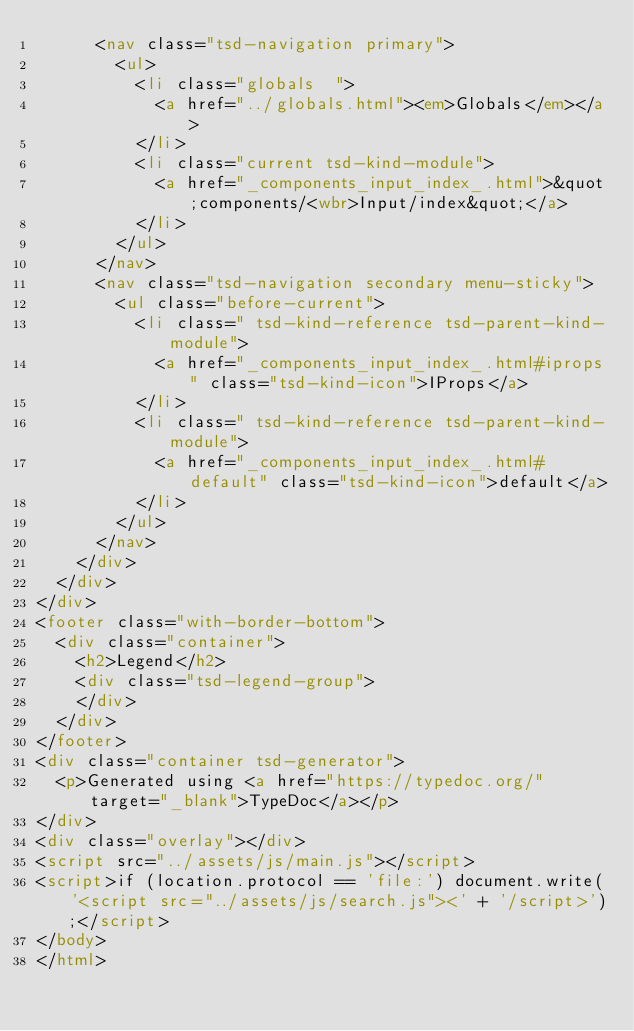Convert code to text. <code><loc_0><loc_0><loc_500><loc_500><_HTML_>			<nav class="tsd-navigation primary">
				<ul>
					<li class="globals  ">
						<a href="../globals.html"><em>Globals</em></a>
					</li>
					<li class="current tsd-kind-module">
						<a href="_components_input_index_.html">&quot;components/<wbr>Input/index&quot;</a>
					</li>
				</ul>
			</nav>
			<nav class="tsd-navigation secondary menu-sticky">
				<ul class="before-current">
					<li class=" tsd-kind-reference tsd-parent-kind-module">
						<a href="_components_input_index_.html#iprops" class="tsd-kind-icon">IProps</a>
					</li>
					<li class=" tsd-kind-reference tsd-parent-kind-module">
						<a href="_components_input_index_.html#default" class="tsd-kind-icon">default</a>
					</li>
				</ul>
			</nav>
		</div>
	</div>
</div>
<footer class="with-border-bottom">
	<div class="container">
		<h2>Legend</h2>
		<div class="tsd-legend-group">
		</div>
	</div>
</footer>
<div class="container tsd-generator">
	<p>Generated using <a href="https://typedoc.org/" target="_blank">TypeDoc</a></p>
</div>
<div class="overlay"></div>
<script src="../assets/js/main.js"></script>
<script>if (location.protocol == 'file:') document.write('<script src="../assets/js/search.js"><' + '/script>');</script>
</body>
</html></code> 